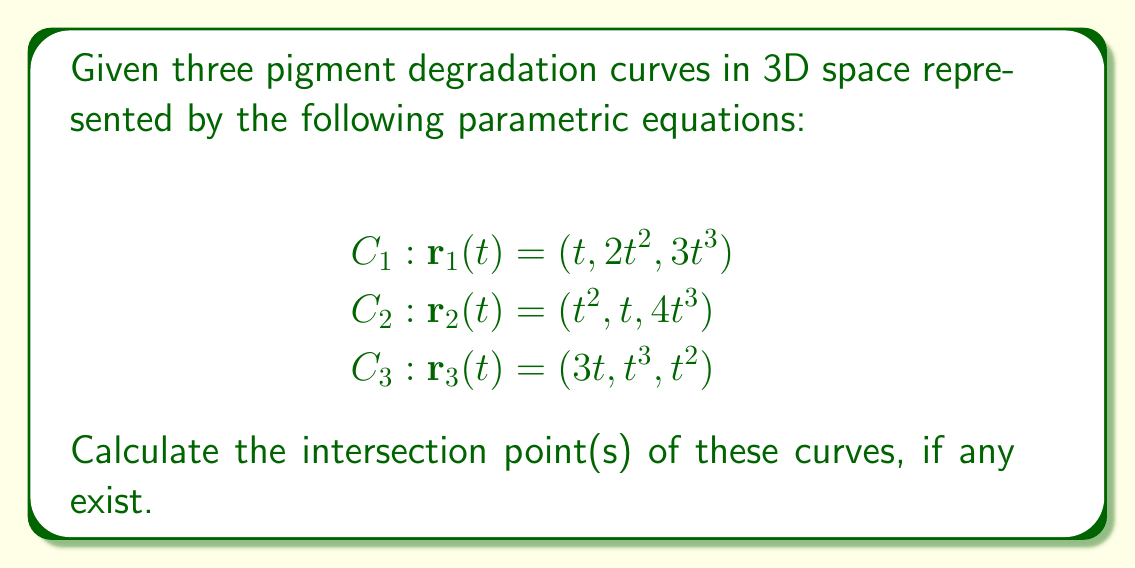Give your solution to this math problem. To find the intersection points of these curves, we need to solve the system of equations:

$$\begin{align*}
t &= t^2 = 3t \\
2t^2 &= t = t^3 \\
3t^3 &= 4t^3 = t^2
\end{align*}$$

Step 1: From the first equation, we can deduce:
$$t = t^2 \implies t(1-t) = 0 \implies t = 0 \text{ or } t = 1$$
Also, $t = 3t \implies 0 = 2t \implies t = 0$

Step 2: From the second equation:
$$2t^2 = t \implies t(2t-1) = 0 \implies t = 0 \text{ or } t = \frac{1}{2}$$
Also, $t = t^3 \implies t(1-t^2) = 0 \implies t = 0 \text{ or } t = \pm 1$

Step 3: From the third equation:
$$3t^3 = t^2 \implies t^2(3t-1) = 0 \implies t = 0 \text{ or } t = \frac{1}{3}$$
Also, $4t^3 = t^2 \implies t^2(4t-1) = 0 \implies t = 0 \text{ or } t = \frac{1}{4}$

Step 4: The only value of $t$ that satisfies all equations simultaneously is $t = 0$.

Step 5: Substituting $t = 0$ into any of the original parametric equations gives us the intersection point:

$$\mathbf{r}(0) = (0, 0, 0)$$

Therefore, the three curves intersect at the origin.
Answer: $(0, 0, 0)$ 